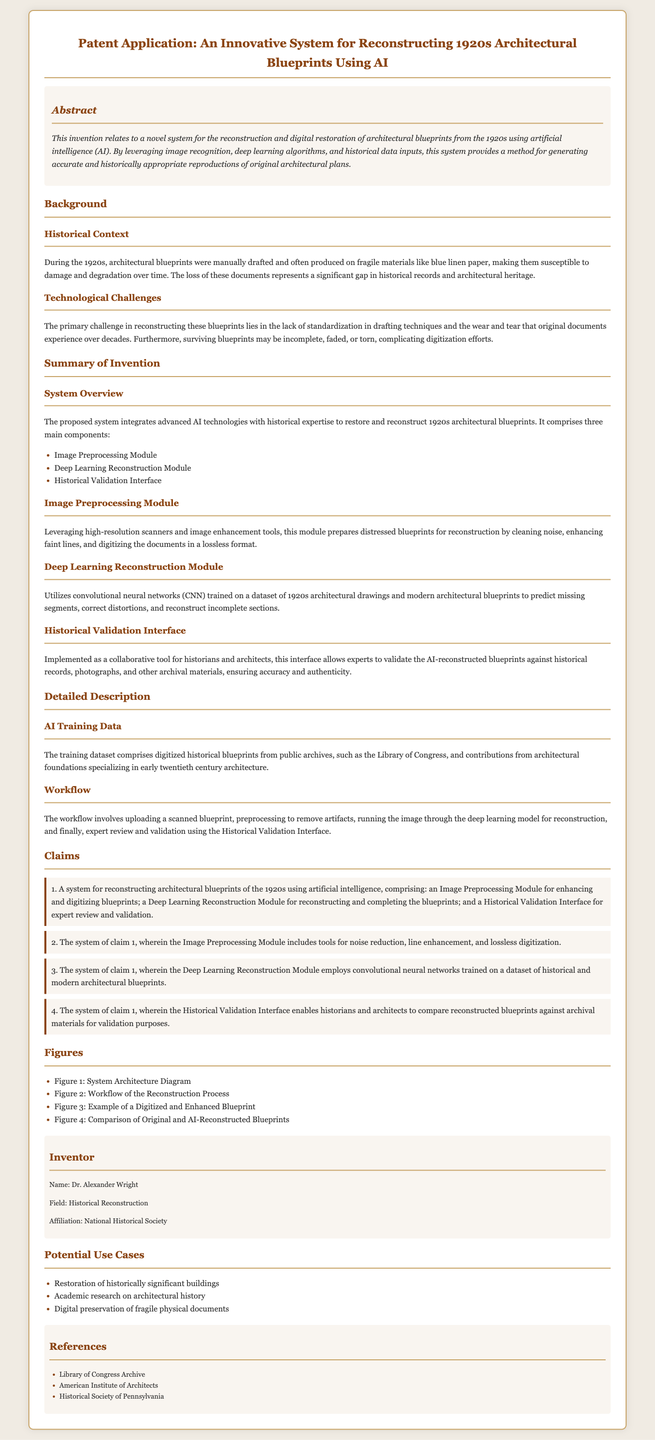What is the title of the patent application? The title is the heading of the document, which describes the invention succinctly.
Answer: An Innovative System for Reconstructing 1920s Architectural Blueprints Using AI Who is the inventor of the system? The inventor's name is provided in the designated section of the document.
Answer: Dr. Alexander Wright What are the three main components of the proposed system? The components are listed in the Summary of Invention section, outlining the structure of the system.
Answer: Image Preprocessing Module, Deep Learning Reconstruction Module, Historical Validation Interface What technology is used in the Deep Learning Reconstruction Module? The document specifies the type of technology employed for reconstruction in the module.
Answer: Convolutional neural networks What is the purpose of the Historical Validation Interface? The function of this interface is explained, detailing its role in the system.
Answer: Expert review and validation How many claims are listed in the document? The Claims section enumerates the points that define the invention's scope.
Answer: Four What type of materials were 1920s blueprints typically drafted on? The document provides specific information on the materials used for drafting during that era.
Answer: Blue linen paper What is the primary challenge mentioned in reconstructing the 1920s blueprints? The challenges are outlined in the Technological Challenges subsection, indicating the key difficulties faced.
Answer: Lack of standardization in drafting techniques What is one potential use case of the innovative system? The Potential Use Cases section lists examples of where this system can be applied.
Answer: Restoration of historically significant buildings 